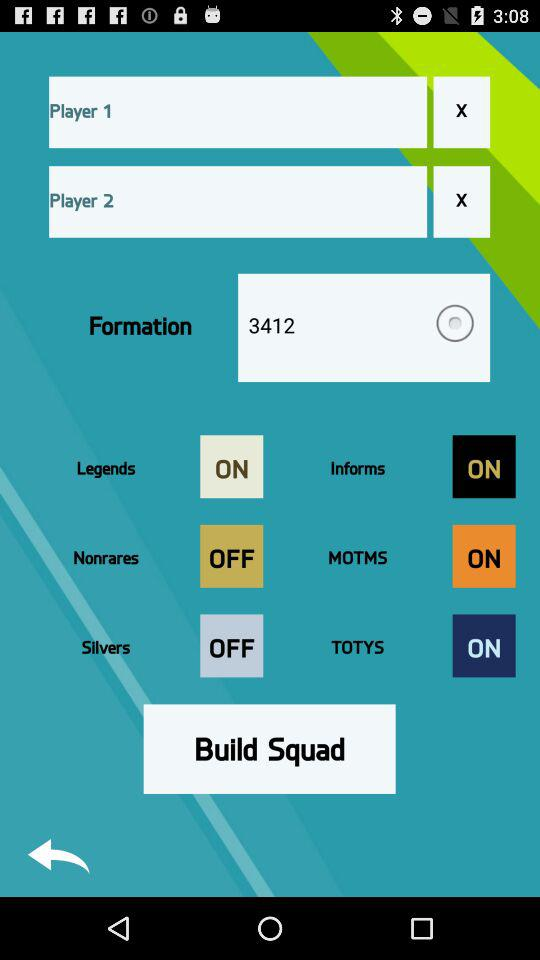What is the selected number for "Formation"? The number is 3412. 